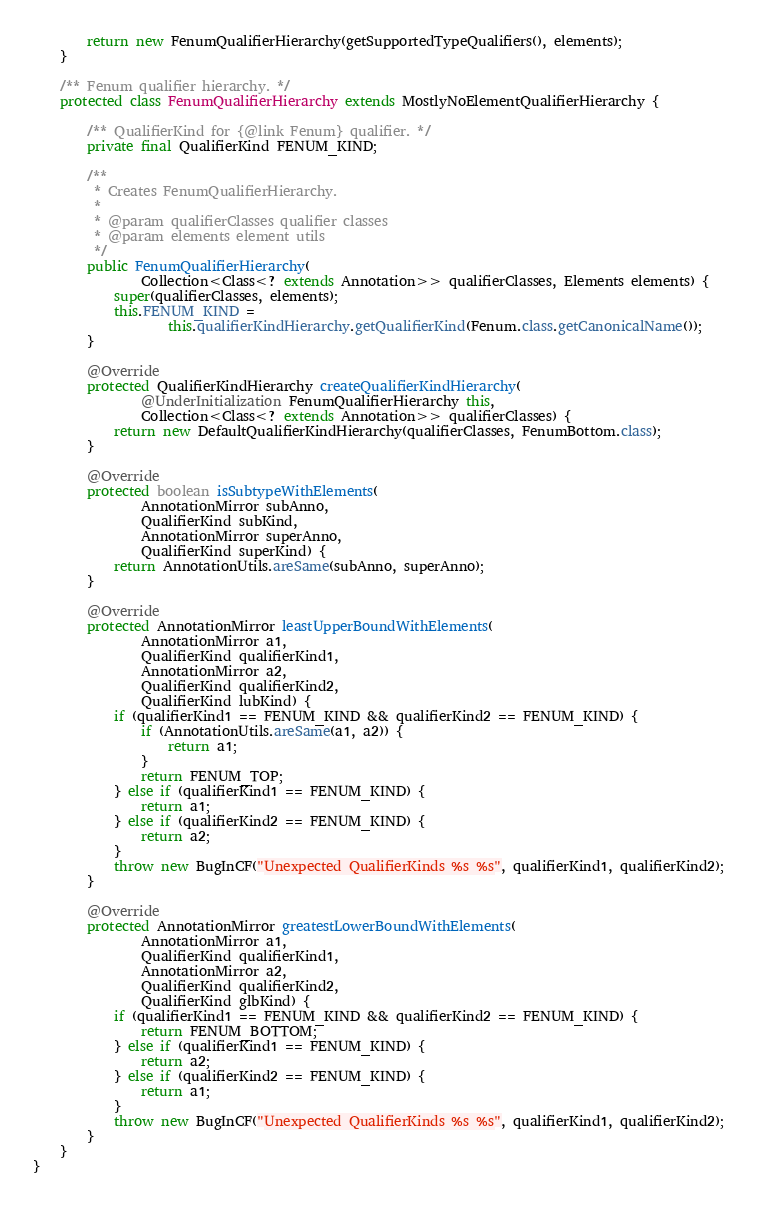Convert code to text. <code><loc_0><loc_0><loc_500><loc_500><_Java_>        return new FenumQualifierHierarchy(getSupportedTypeQualifiers(), elements);
    }

    /** Fenum qualifier hierarchy. */
    protected class FenumQualifierHierarchy extends MostlyNoElementQualifierHierarchy {

        /** QualifierKind for {@link Fenum} qualifier. */
        private final QualifierKind FENUM_KIND;

        /**
         * Creates FenumQualifierHierarchy.
         *
         * @param qualifierClasses qualifier classes
         * @param elements element utils
         */
        public FenumQualifierHierarchy(
                Collection<Class<? extends Annotation>> qualifierClasses, Elements elements) {
            super(qualifierClasses, elements);
            this.FENUM_KIND =
                    this.qualifierKindHierarchy.getQualifierKind(Fenum.class.getCanonicalName());
        }

        @Override
        protected QualifierKindHierarchy createQualifierKindHierarchy(
                @UnderInitialization FenumQualifierHierarchy this,
                Collection<Class<? extends Annotation>> qualifierClasses) {
            return new DefaultQualifierKindHierarchy(qualifierClasses, FenumBottom.class);
        }

        @Override
        protected boolean isSubtypeWithElements(
                AnnotationMirror subAnno,
                QualifierKind subKind,
                AnnotationMirror superAnno,
                QualifierKind superKind) {
            return AnnotationUtils.areSame(subAnno, superAnno);
        }

        @Override
        protected AnnotationMirror leastUpperBoundWithElements(
                AnnotationMirror a1,
                QualifierKind qualifierKind1,
                AnnotationMirror a2,
                QualifierKind qualifierKind2,
                QualifierKind lubKind) {
            if (qualifierKind1 == FENUM_KIND && qualifierKind2 == FENUM_KIND) {
                if (AnnotationUtils.areSame(a1, a2)) {
                    return a1;
                }
                return FENUM_TOP;
            } else if (qualifierKind1 == FENUM_KIND) {
                return a1;
            } else if (qualifierKind2 == FENUM_KIND) {
                return a2;
            }
            throw new BugInCF("Unexpected QualifierKinds %s %s", qualifierKind1, qualifierKind2);
        }

        @Override
        protected AnnotationMirror greatestLowerBoundWithElements(
                AnnotationMirror a1,
                QualifierKind qualifierKind1,
                AnnotationMirror a2,
                QualifierKind qualifierKind2,
                QualifierKind glbKind) {
            if (qualifierKind1 == FENUM_KIND && qualifierKind2 == FENUM_KIND) {
                return FENUM_BOTTOM;
            } else if (qualifierKind1 == FENUM_KIND) {
                return a2;
            } else if (qualifierKind2 == FENUM_KIND) {
                return a1;
            }
            throw new BugInCF("Unexpected QualifierKinds %s %s", qualifierKind1, qualifierKind2);
        }
    }
}
</code> 